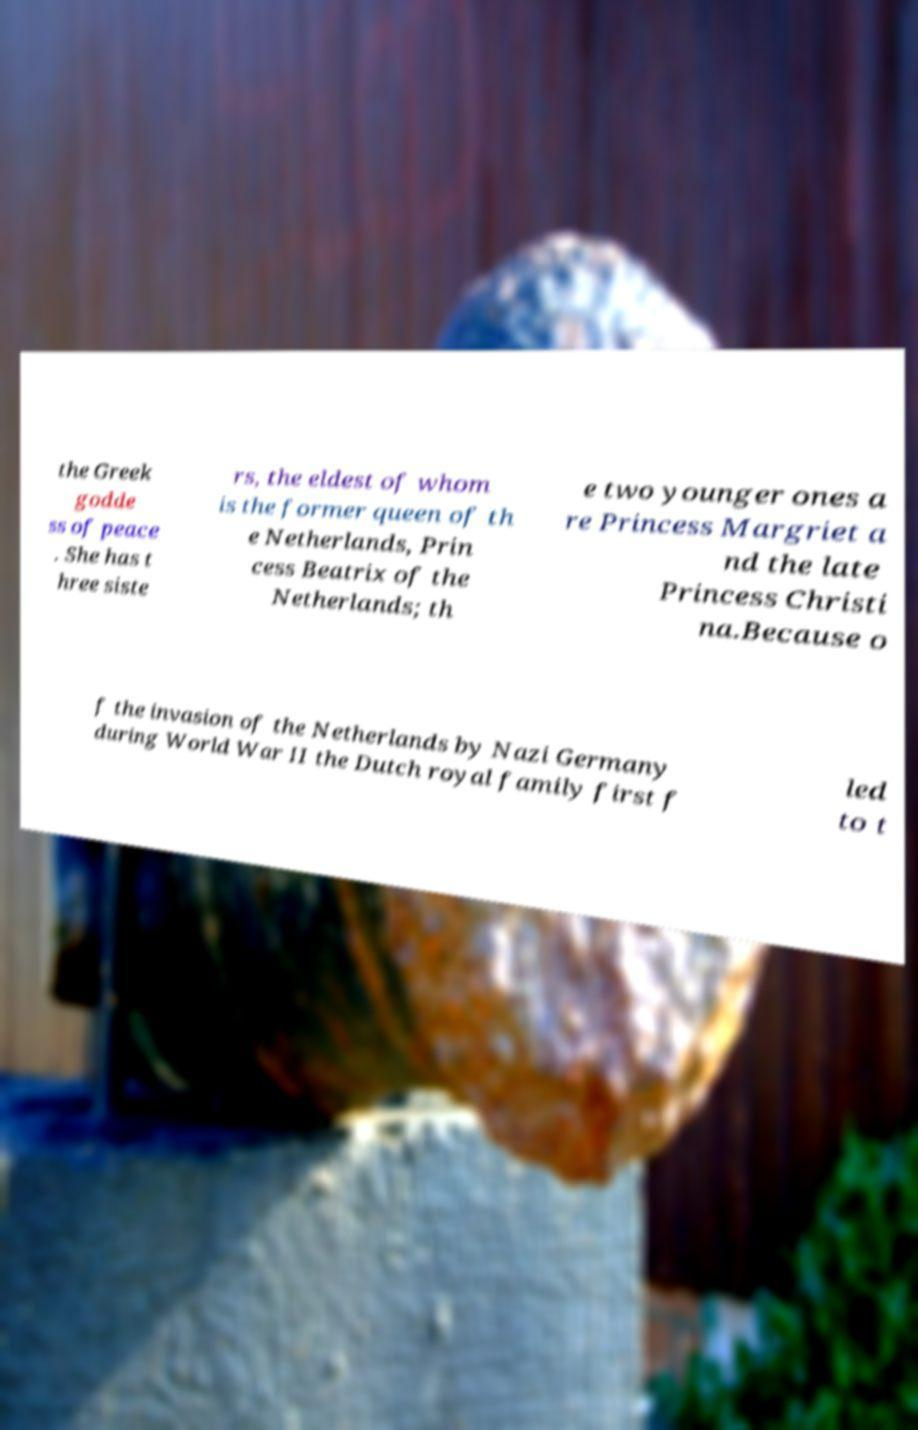Could you assist in decoding the text presented in this image and type it out clearly? the Greek godde ss of peace . She has t hree siste rs, the eldest of whom is the former queen of th e Netherlands, Prin cess Beatrix of the Netherlands; th e two younger ones a re Princess Margriet a nd the late Princess Christi na.Because o f the invasion of the Netherlands by Nazi Germany during World War II the Dutch royal family first f led to t 